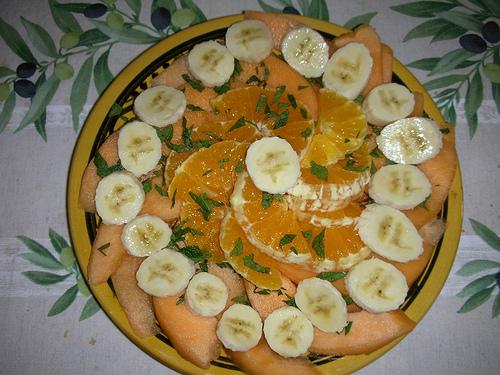How many slices of banana?
Keep it brief. 19. What color is the tablecloth covering the table?
Keep it brief. White. Which fruits are in the salad?
Concise answer only. Banana. 